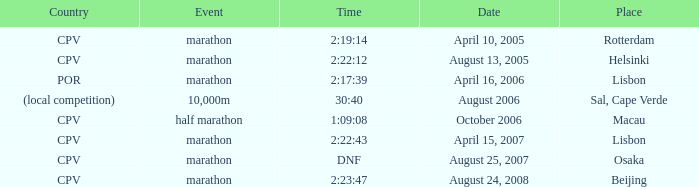Where is the half marathon event held, in terms of country? CPV. 